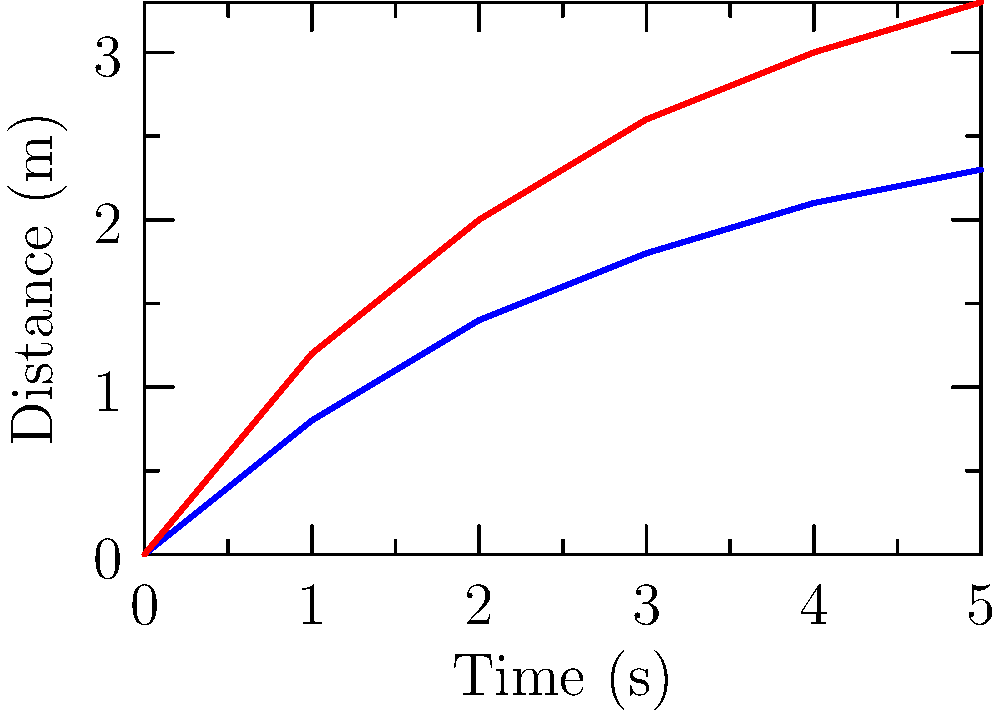Based on the graph showing the distance traveled by smooth and rough baseballs over time, which type of baseball appears to experience less air resistance? How might this information be used to expose corrupt practices in baseball? To answer this question, we need to analyze the graph and understand the relationship between air resistance and ball movement:

1. The graph shows two lines: blue for smooth baseballs and red for rough baseballs.

2. The y-axis represents distance traveled, while the x-axis shows time.

3. Air resistance affects the speed and distance a ball can travel. Less air resistance means the ball can travel farther in the same amount of time.

4. Comparing the two lines, we can see that the red line (rough baseball) is consistently higher than the blue line (smooth baseball) at each time point.

5. This indicates that the rough baseball travels a greater distance in the same amount of time compared to the smooth baseball.

6. Therefore, the rough baseball appears to experience less air resistance, allowing it to travel farther.

7. In terms of exposing corrupt practices, this information could be used to show that:
   a) Some teams or manufacturers might be intentionally altering ball surfaces to gain an unfair advantage.
   b) The league might be allowing or even encouraging the use of balls with specific textures to influence game outcomes or increase offensive statistics.

8. A disgruntled team manager could use this data to demonstrate how seemingly small changes in ball texture can significantly impact game play, potentially manipulating results and player statistics.
Answer: Rough baseballs; expose ball tampering or league manipulation of equipment standards. 